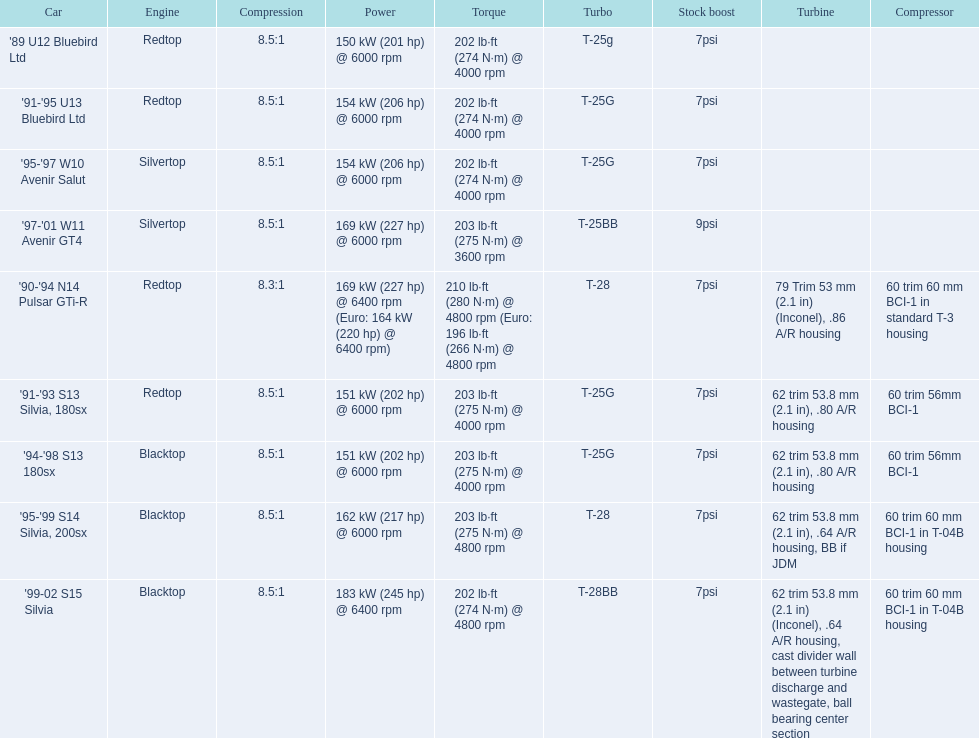What are all the vehicles? '89 U12 Bluebird Ltd, '91-'95 U13 Bluebird Ltd, '95-'97 W10 Avenir Salut, '97-'01 W11 Avenir GT4, '90-'94 N14 Pulsar GTi-R, '91-'93 S13 Silvia, 180sx, '94-'98 S13 180sx, '95-'99 S14 Silvia, 200sx, '99-02 S15 Silvia. What is their rated capacity? 150 kW (201 hp) @ 6000 rpm, 154 kW (206 hp) @ 6000 rpm, 154 kW (206 hp) @ 6000 rpm, 169 kW (227 hp) @ 6000 rpm, 169 kW (227 hp) @ 6400 rpm (Euro: 164 kW (220 hp) @ 6400 rpm), 151 kW (202 hp) @ 6000 rpm, 151 kW (202 hp) @ 6000 rpm, 162 kW (217 hp) @ 6000 rpm, 183 kW (245 hp) @ 6400 rpm. Which car has the highest power? '99-02 S15 Silvia. 